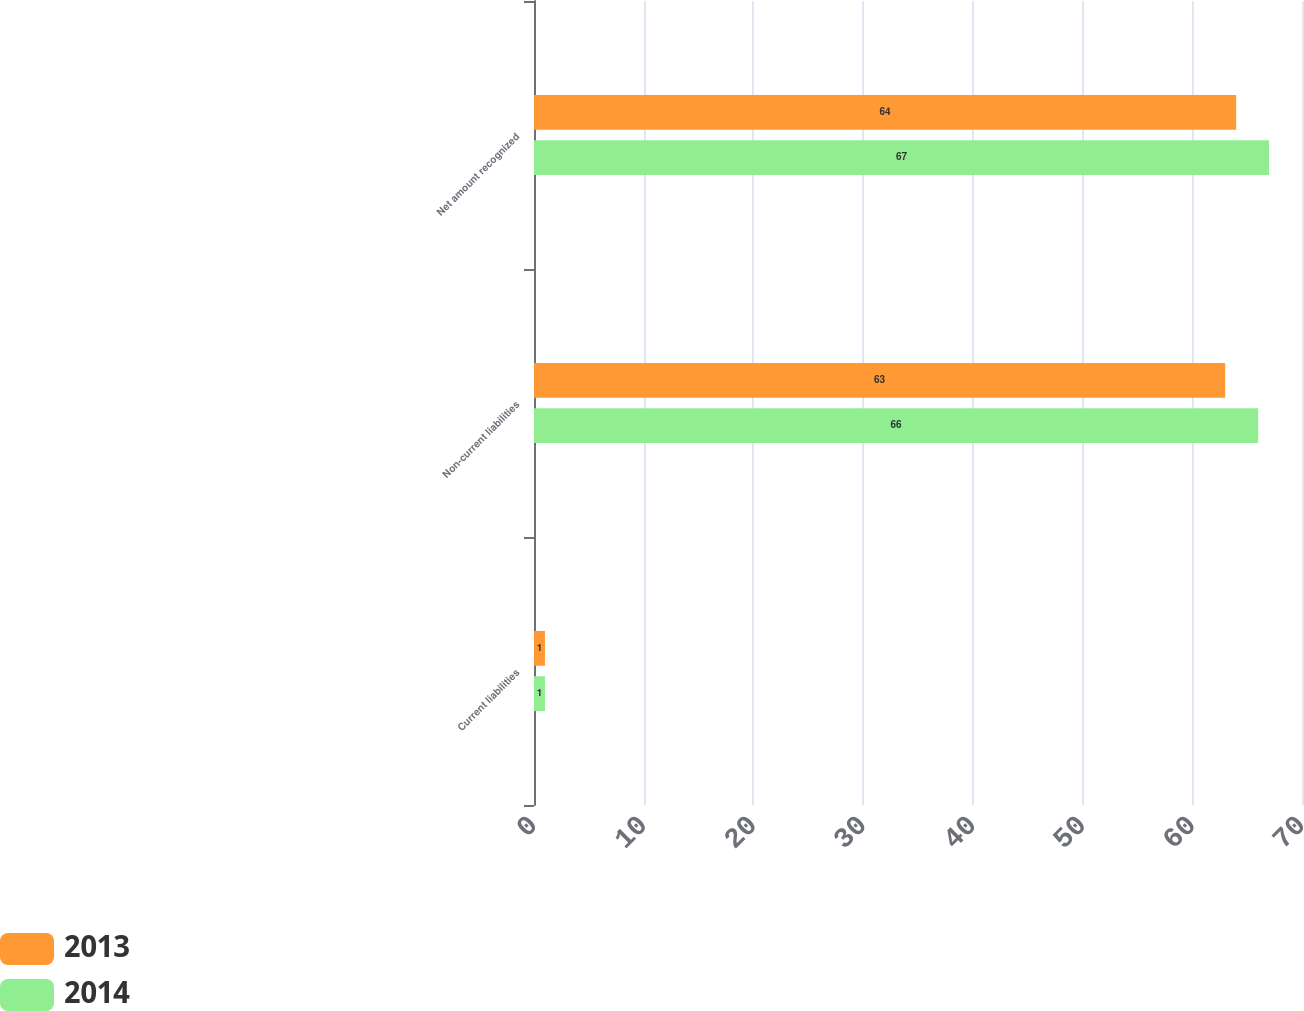Convert chart. <chart><loc_0><loc_0><loc_500><loc_500><stacked_bar_chart><ecel><fcel>Current liabilities<fcel>Non-current liabilities<fcel>Net amount recognized<nl><fcel>2013<fcel>1<fcel>63<fcel>64<nl><fcel>2014<fcel>1<fcel>66<fcel>67<nl></chart> 